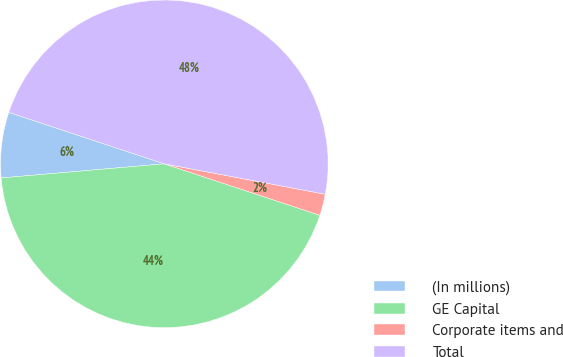<chart> <loc_0><loc_0><loc_500><loc_500><pie_chart><fcel>(In millions)<fcel>GE Capital<fcel>Corporate items and<fcel>Total<nl><fcel>6.46%<fcel>43.54%<fcel>2.11%<fcel>47.89%<nl></chart> 